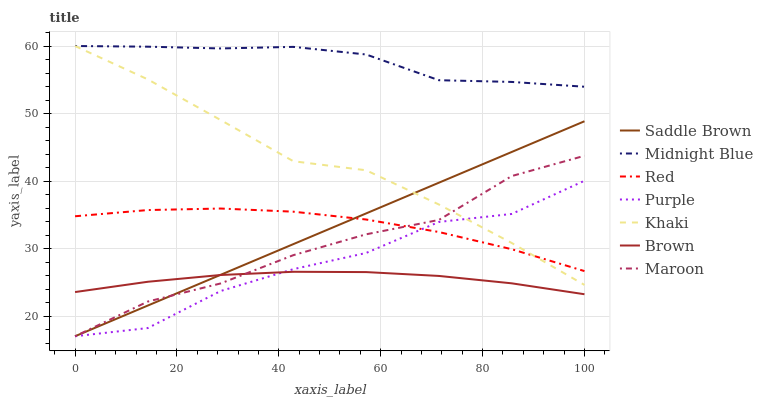Does Brown have the minimum area under the curve?
Answer yes or no. Yes. Does Midnight Blue have the maximum area under the curve?
Answer yes or no. Yes. Does Khaki have the minimum area under the curve?
Answer yes or no. No. Does Khaki have the maximum area under the curve?
Answer yes or no. No. Is Saddle Brown the smoothest?
Answer yes or no. Yes. Is Purple the roughest?
Answer yes or no. Yes. Is Khaki the smoothest?
Answer yes or no. No. Is Khaki the roughest?
Answer yes or no. No. Does Khaki have the lowest value?
Answer yes or no. No. Does Purple have the highest value?
Answer yes or no. No. Is Brown less than Khaki?
Answer yes or no. Yes. Is Khaki greater than Brown?
Answer yes or no. Yes. Does Brown intersect Khaki?
Answer yes or no. No. 